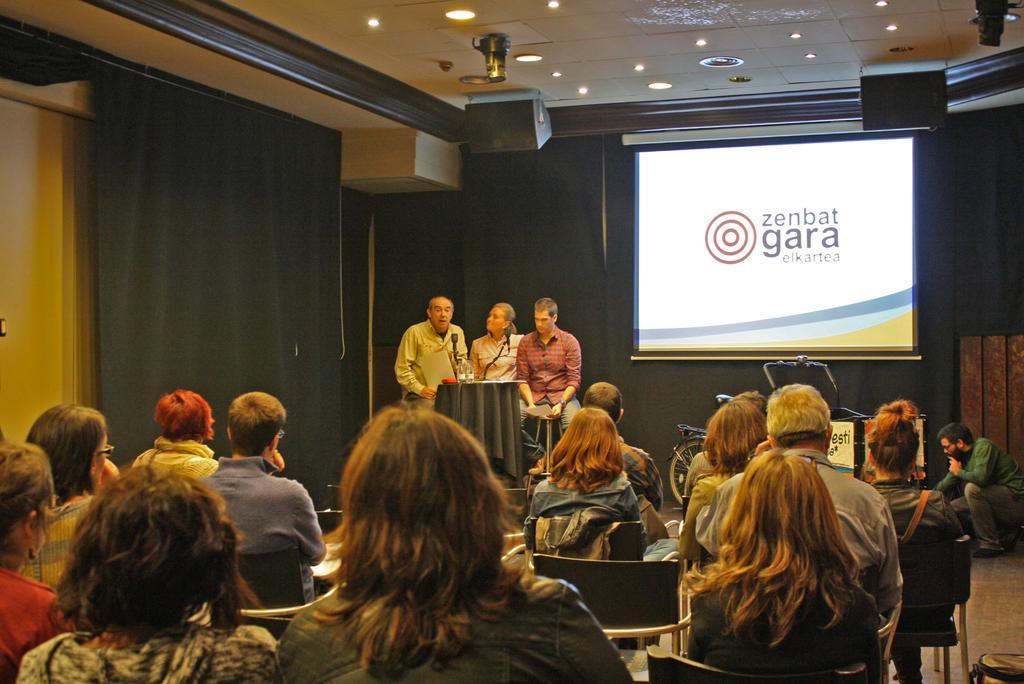Describe this image in one or two sentences. In this picture there are group of people sitting. At the back there are three persons sitting behind the table and there is a microphone and there is an object on the table and the table is covered with black color cloth. At the back there is a bicycle and there is a screen and there is a text on the screen. On the left side of the image there is a curtain. At the back there is a curtain. At the top there are lights and speakers. 